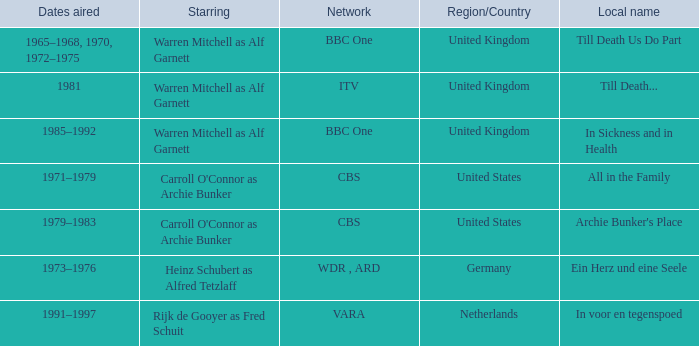Could you help me parse every detail presented in this table? {'header': ['Dates aired', 'Starring', 'Network', 'Region/Country', 'Local name'], 'rows': [['1965–1968, 1970, 1972–1975', 'Warren Mitchell as Alf Garnett', 'BBC One', 'United Kingdom', 'Till Death Us Do Part'], ['1981', 'Warren Mitchell as Alf Garnett', 'ITV', 'United Kingdom', 'Till Death...'], ['1985–1992', 'Warren Mitchell as Alf Garnett', 'BBC One', 'United Kingdom', 'In Sickness and in Health'], ['1971–1979', "Carroll O'Connor as Archie Bunker", 'CBS', 'United States', 'All in the Family'], ['1979–1983', "Carroll O'Connor as Archie Bunker", 'CBS', 'United States', "Archie Bunker's Place"], ['1973–1976', 'Heinz Schubert as Alfred Tetzlaff', 'WDR , ARD', 'Germany', 'Ein Herz und eine Seele'], ['1991–1997', 'Rijk de Gooyer as Fred Schuit', 'VARA', 'Netherlands', 'In voor en tegenspoed']]} What dates did the episodes air in the United States? 1971–1979, 1979–1983. 